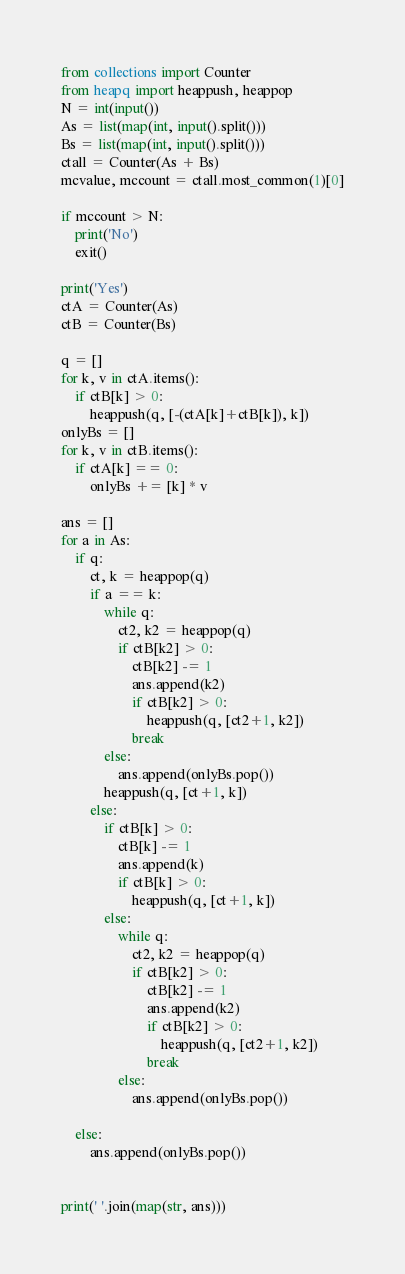<code> <loc_0><loc_0><loc_500><loc_500><_Python_>from collections import Counter
from heapq import heappush, heappop
N = int(input())
As = list(map(int, input().split()))
Bs = list(map(int, input().split()))
ctall = Counter(As + Bs)
mcvalue, mccount = ctall.most_common(1)[0]

if mccount > N:
    print('No')
    exit()

print('Yes')
ctA = Counter(As)
ctB = Counter(Bs)

q = []
for k, v in ctA.items():
    if ctB[k] > 0:
        heappush(q, [-(ctA[k]+ctB[k]), k])
onlyBs = []
for k, v in ctB.items():
    if ctA[k] == 0:
        onlyBs += [k] * v

ans = []
for a in As:
    if q:
        ct, k = heappop(q)
        if a == k:
            while q:
                ct2, k2 = heappop(q)
                if ctB[k2] > 0:
                    ctB[k2] -= 1
                    ans.append(k2)
                    if ctB[k2] > 0:
                        heappush(q, [ct2+1, k2])
                    break
            else:
                ans.append(onlyBs.pop())
            heappush(q, [ct+1, k])
        else:
            if ctB[k] > 0:
                ctB[k] -= 1
                ans.append(k)
                if ctB[k] > 0:
                    heappush(q, [ct+1, k])
            else:
                while q:
                    ct2, k2 = heappop(q)
                    if ctB[k2] > 0:
                        ctB[k2] -= 1
                        ans.append(k2)
                        if ctB[k2] > 0:
                            heappush(q, [ct2+1, k2])
                        break
                else:
                    ans.append(onlyBs.pop())

    else:
        ans.append(onlyBs.pop())


print(' '.join(map(str, ans)))
</code> 